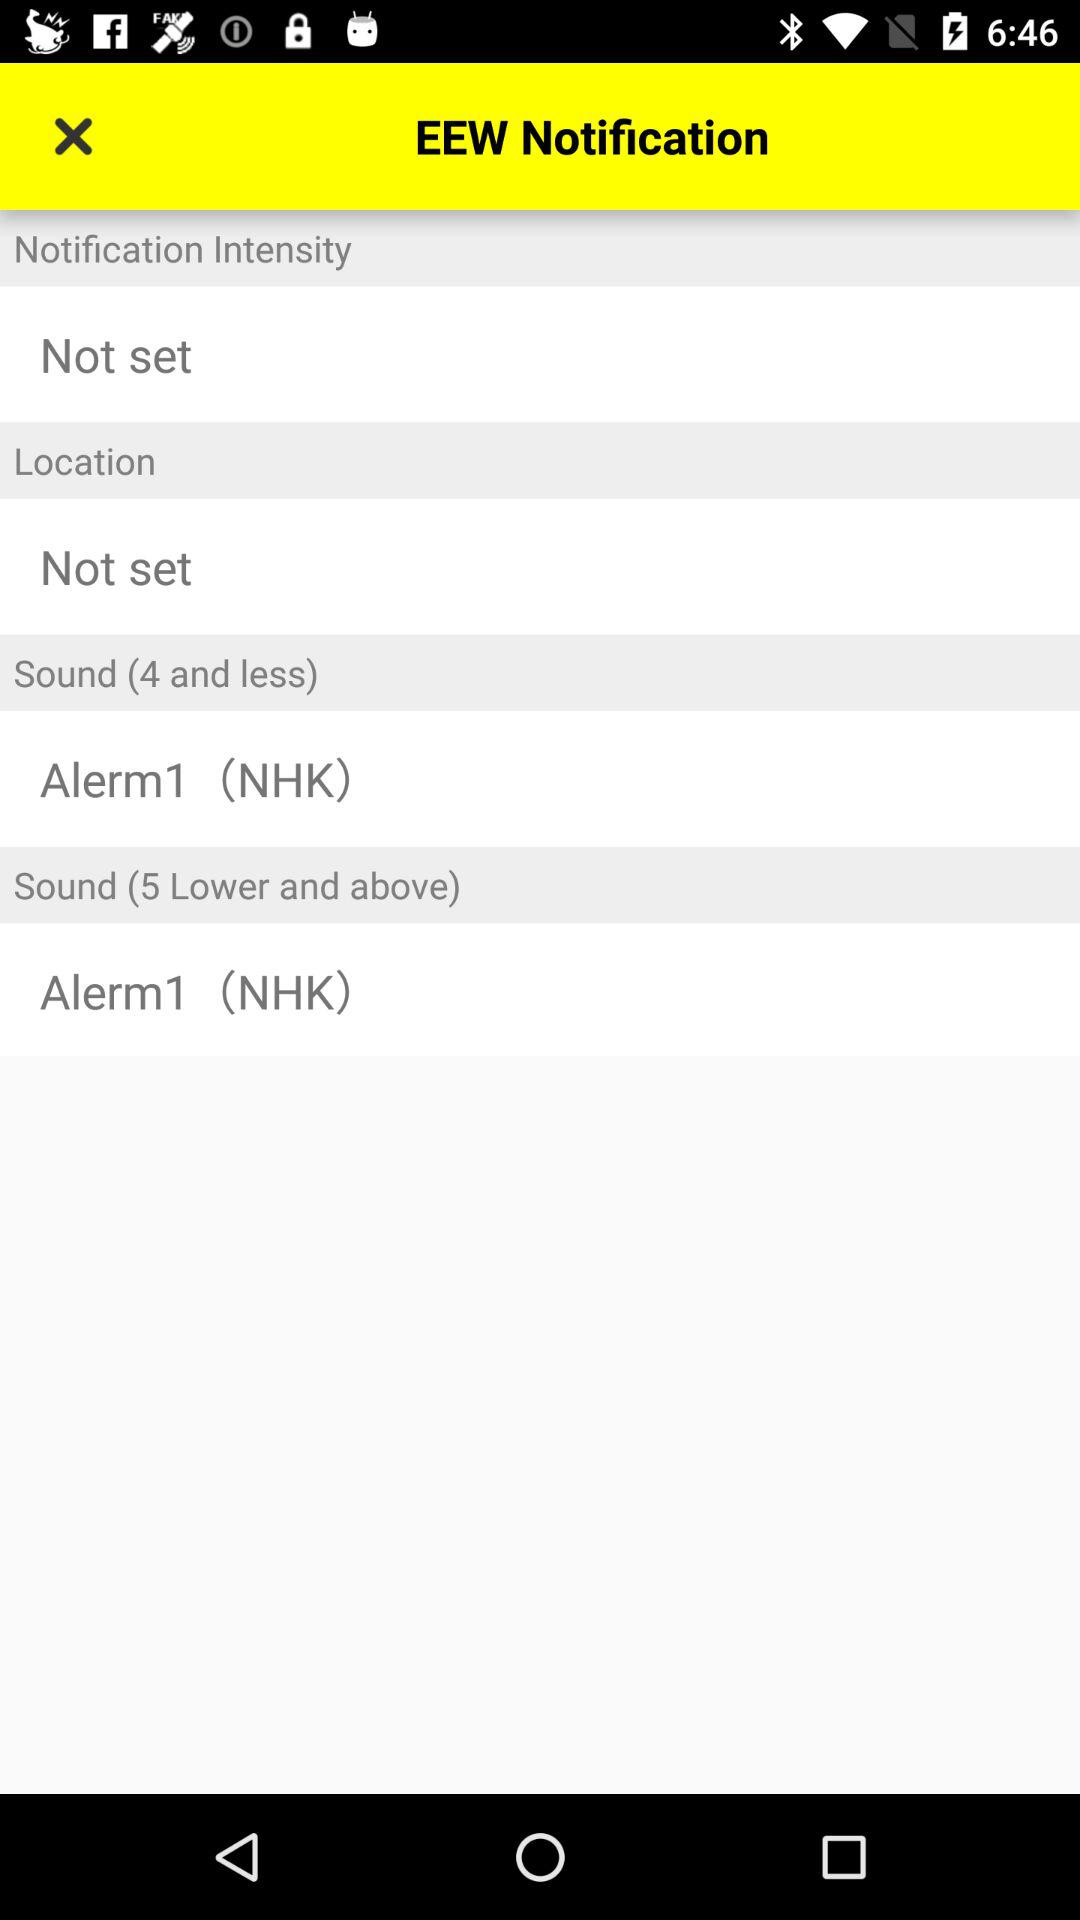What is the application name? The application name is "EEW". 